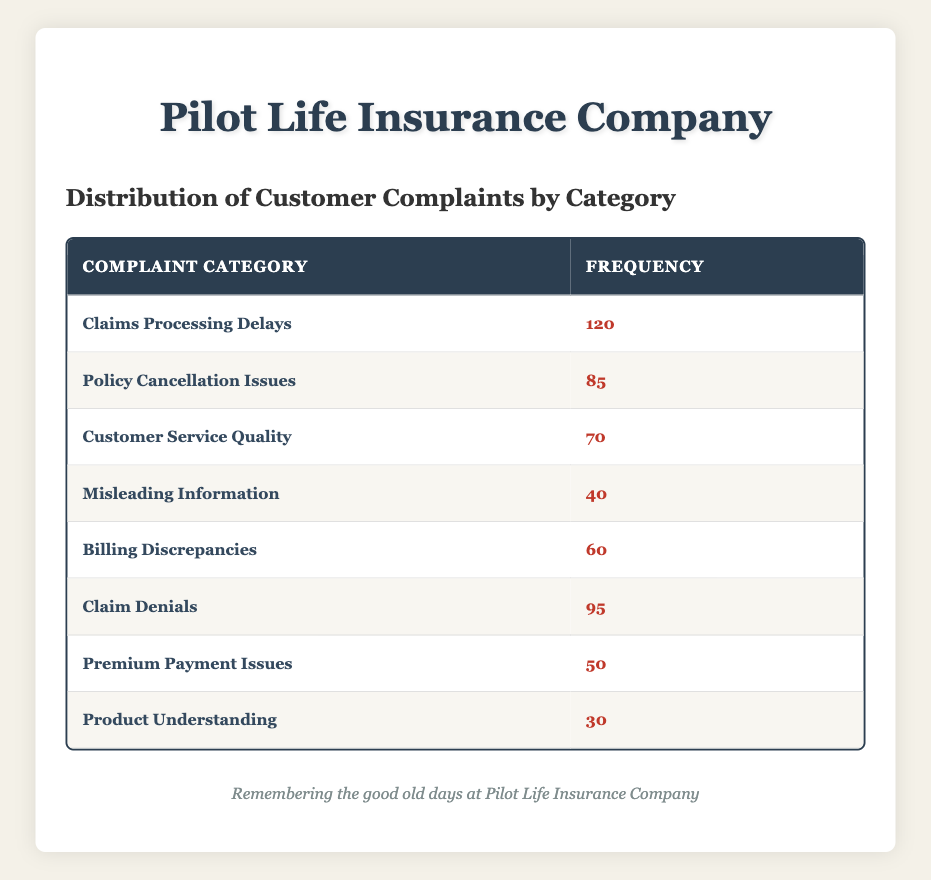What is the highest frequency of complaints in the table? The highest frequency can be found by looking through the frequency values in the table. Scanning through the values, "Claims Processing Delays" has 120, which is the largest.
Answer: 120 How many complaints are related to "Billing Discrepancies"? The table explicitly lists the frequency of complaints for each category. "Billing Discrepancies" has a frequency of 60.
Answer: 60 Is "Product Understanding" category one of the top three complaints? To determine if it is in the top three, we need to look at the frequencies. The top three complaints are "Claims Processing Delays" (120), "Claim Denials" (95), and "Policy Cancellation Issues" (85). Since "Product Understanding" has only 30, it is not in the top three.
Answer: No What is the total number of complaints listed in the table? To find the total number, we sum all the frequency values: 120 + 85 + 70 + 40 + 60 + 95 + 50 + 30 = 550. Thus, the total number of complaints is 550.
Answer: 550 Which complaint category has a frequency closest to 50? We will compare the frequencies of all categories to find the one closest to 50. The category "Premium Payment Issues" has exactly 50, while "Billing Discrepancies" has 60, and "Customer Service Quality" has 70, but no others come closer without exceeding it. Therefore, "Premium Payment Issues" is the answer.
Answer: Premium Payment Issues What is the difference between the highest and lowest complaint frequencies? The highest frequency is 120 (from "Claims Processing Delays"), and the lowest frequency is 30 (from "Product Understanding"). The difference is calculated by subtracting the lowest from the highest: 120 - 30 = 90.
Answer: 90 How many complaints were made regarding "Misleading Information" and "Claims Processing Delays" combined? To find the combined total, we add their individual frequencies: "Misleading Information" has 40, and "Claims Processing Delays" has 120. Therefore, 120 + 40 = 160.
Answer: 160 Is there a complaint category with a frequency greater than 100? Checking the frequency values reveals that "Claims Processing Delays" has 120, which is greater than 100. Hence, there is at least one category that meets this criterion.
Answer: Yes Which category had more complaints, "Customer Service Quality" or "Claim Denials"? "Customer Service Quality" has a frequency of 70 while "Claim Denials" has a frequency of 95. Comparing these values shows that "Claim Denials" had more complaints than "Customer Service Quality."
Answer: Claim Denials 